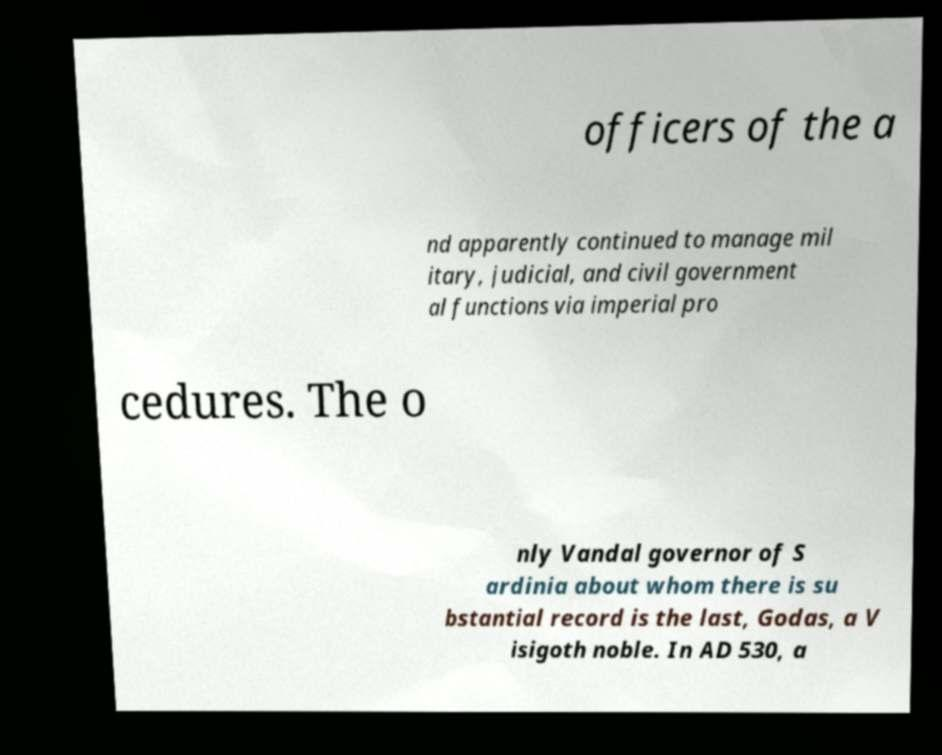Could you extract and type out the text from this image? officers of the a nd apparently continued to manage mil itary, judicial, and civil government al functions via imperial pro cedures. The o nly Vandal governor of S ardinia about whom there is su bstantial record is the last, Godas, a V isigoth noble. In AD 530, a 